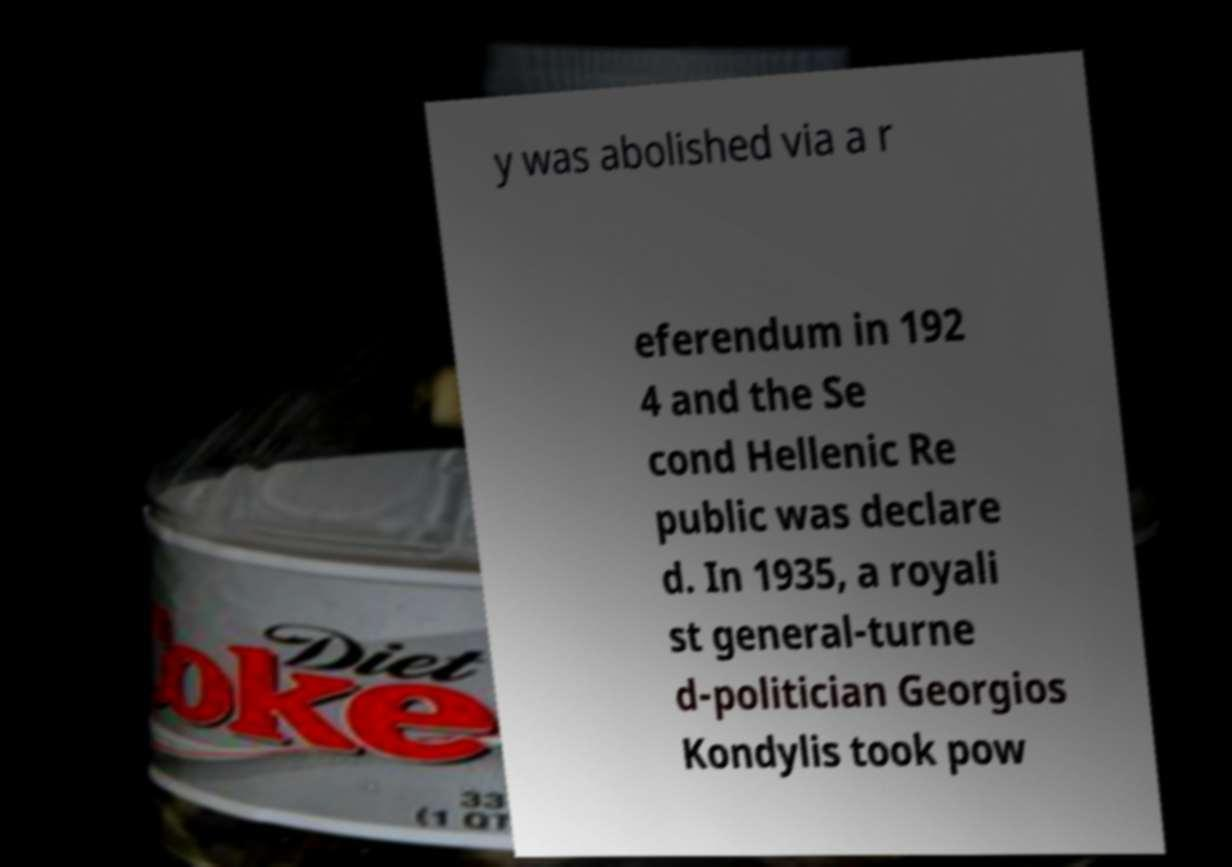Could you assist in decoding the text presented in this image and type it out clearly? y was abolished via a r eferendum in 192 4 and the Se cond Hellenic Re public was declare d. In 1935, a royali st general-turne d-politician Georgios Kondylis took pow 